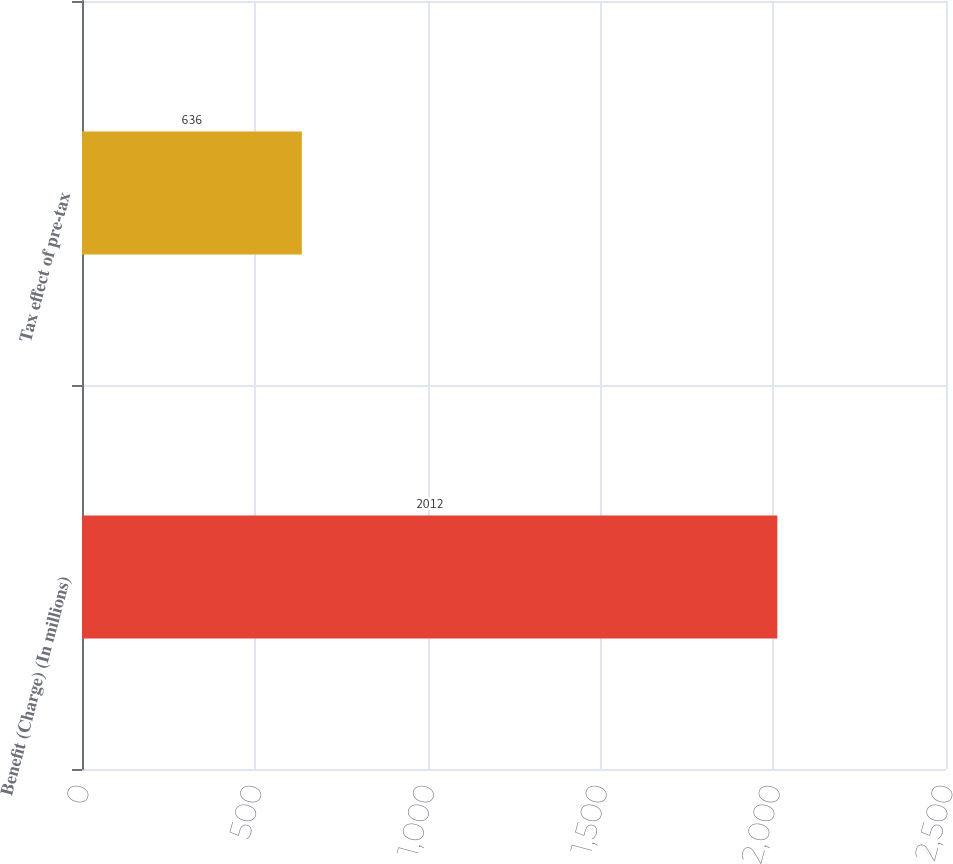Convert chart to OTSL. <chart><loc_0><loc_0><loc_500><loc_500><bar_chart><fcel>Benefit (Charge) (In millions)<fcel>Tax effect of pre-tax<nl><fcel>2012<fcel>636<nl></chart> 